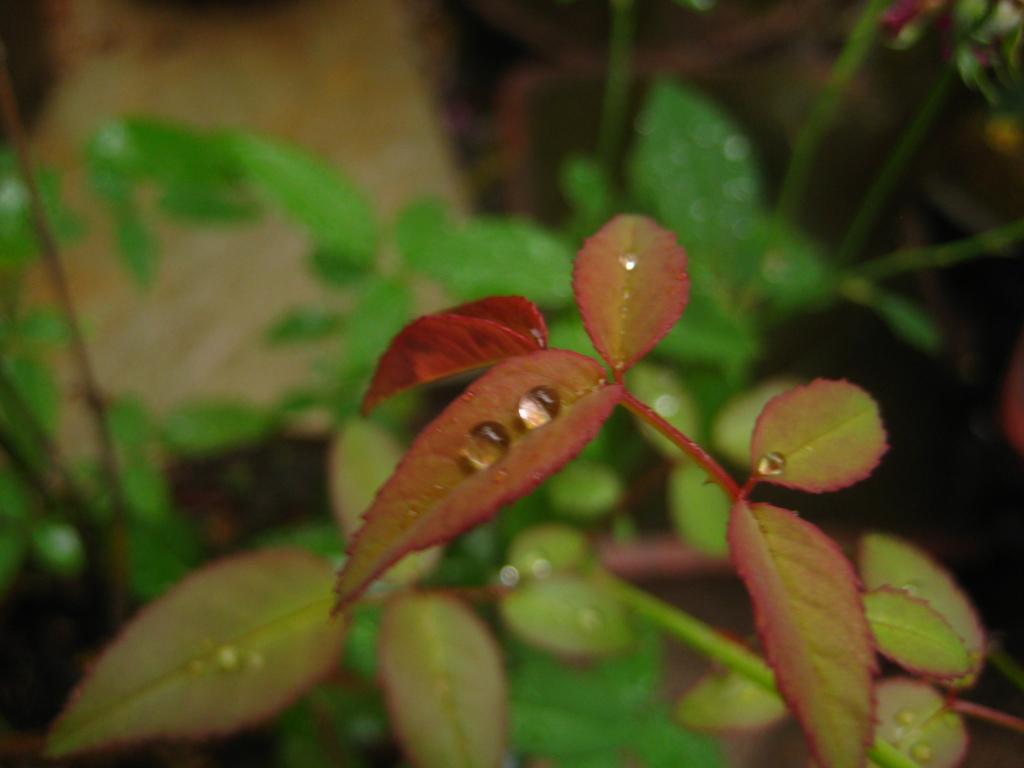Can you describe this image briefly? In this image, we can see plant leaves and water droplets. Background there is a blur view. 